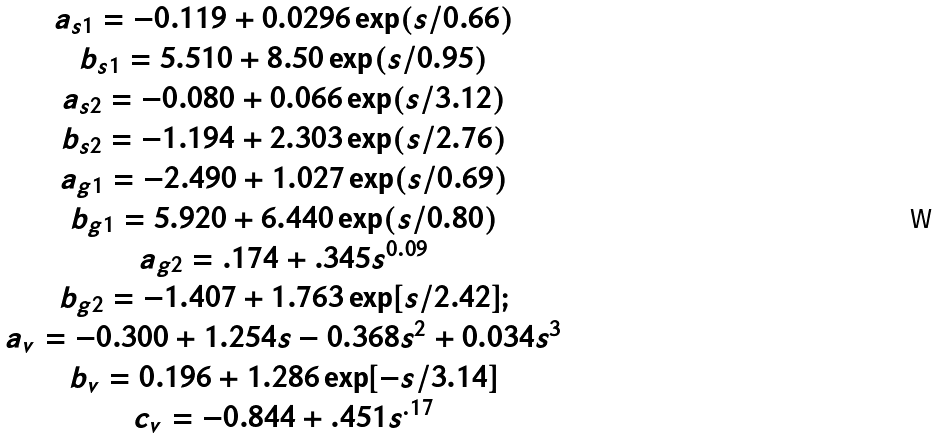<formula> <loc_0><loc_0><loc_500><loc_500>\begin{array} { c } a _ { s 1 } = - 0 . 1 1 9 + 0 . 0 2 9 6 \exp ( s / 0 . 6 6 ) \\ b _ { s 1 } = 5 . 5 1 0 + 8 . 5 0 \exp ( s / 0 . 9 5 ) \\ a _ { s 2 } = - 0 . 0 8 0 + 0 . 0 6 6 \exp ( s / 3 . 1 2 ) \\ b _ { s 2 } = - 1 . 1 9 4 + 2 . 3 0 3 \exp ( s / 2 . 7 6 ) \\ a _ { g 1 } = - 2 . 4 9 0 + 1 . 0 2 7 \exp ( s / 0 . 6 9 ) \\ b _ { g 1 } = 5 . 9 2 0 + 6 . 4 4 0 \exp ( s / 0 . 8 0 ) \\ a _ { g 2 } = . 1 7 4 + . 3 4 5 s ^ { 0 . 0 9 } \\ b _ { g 2 } = - 1 . 4 0 7 + 1 . 7 6 3 \exp [ s / 2 . 4 2 ] ; \\ a _ { v } = - 0 . 3 0 0 + 1 . 2 5 4 s - 0 . 3 6 8 s ^ { 2 } + 0 . 0 3 4 s ^ { 3 } \\ b _ { v } = 0 . 1 9 6 + 1 . 2 8 6 \exp [ - s / 3 . 1 4 ] \\ c _ { v } = - 0 . 8 4 4 + . 4 5 1 s ^ { . 1 7 } \end{array}</formula> 